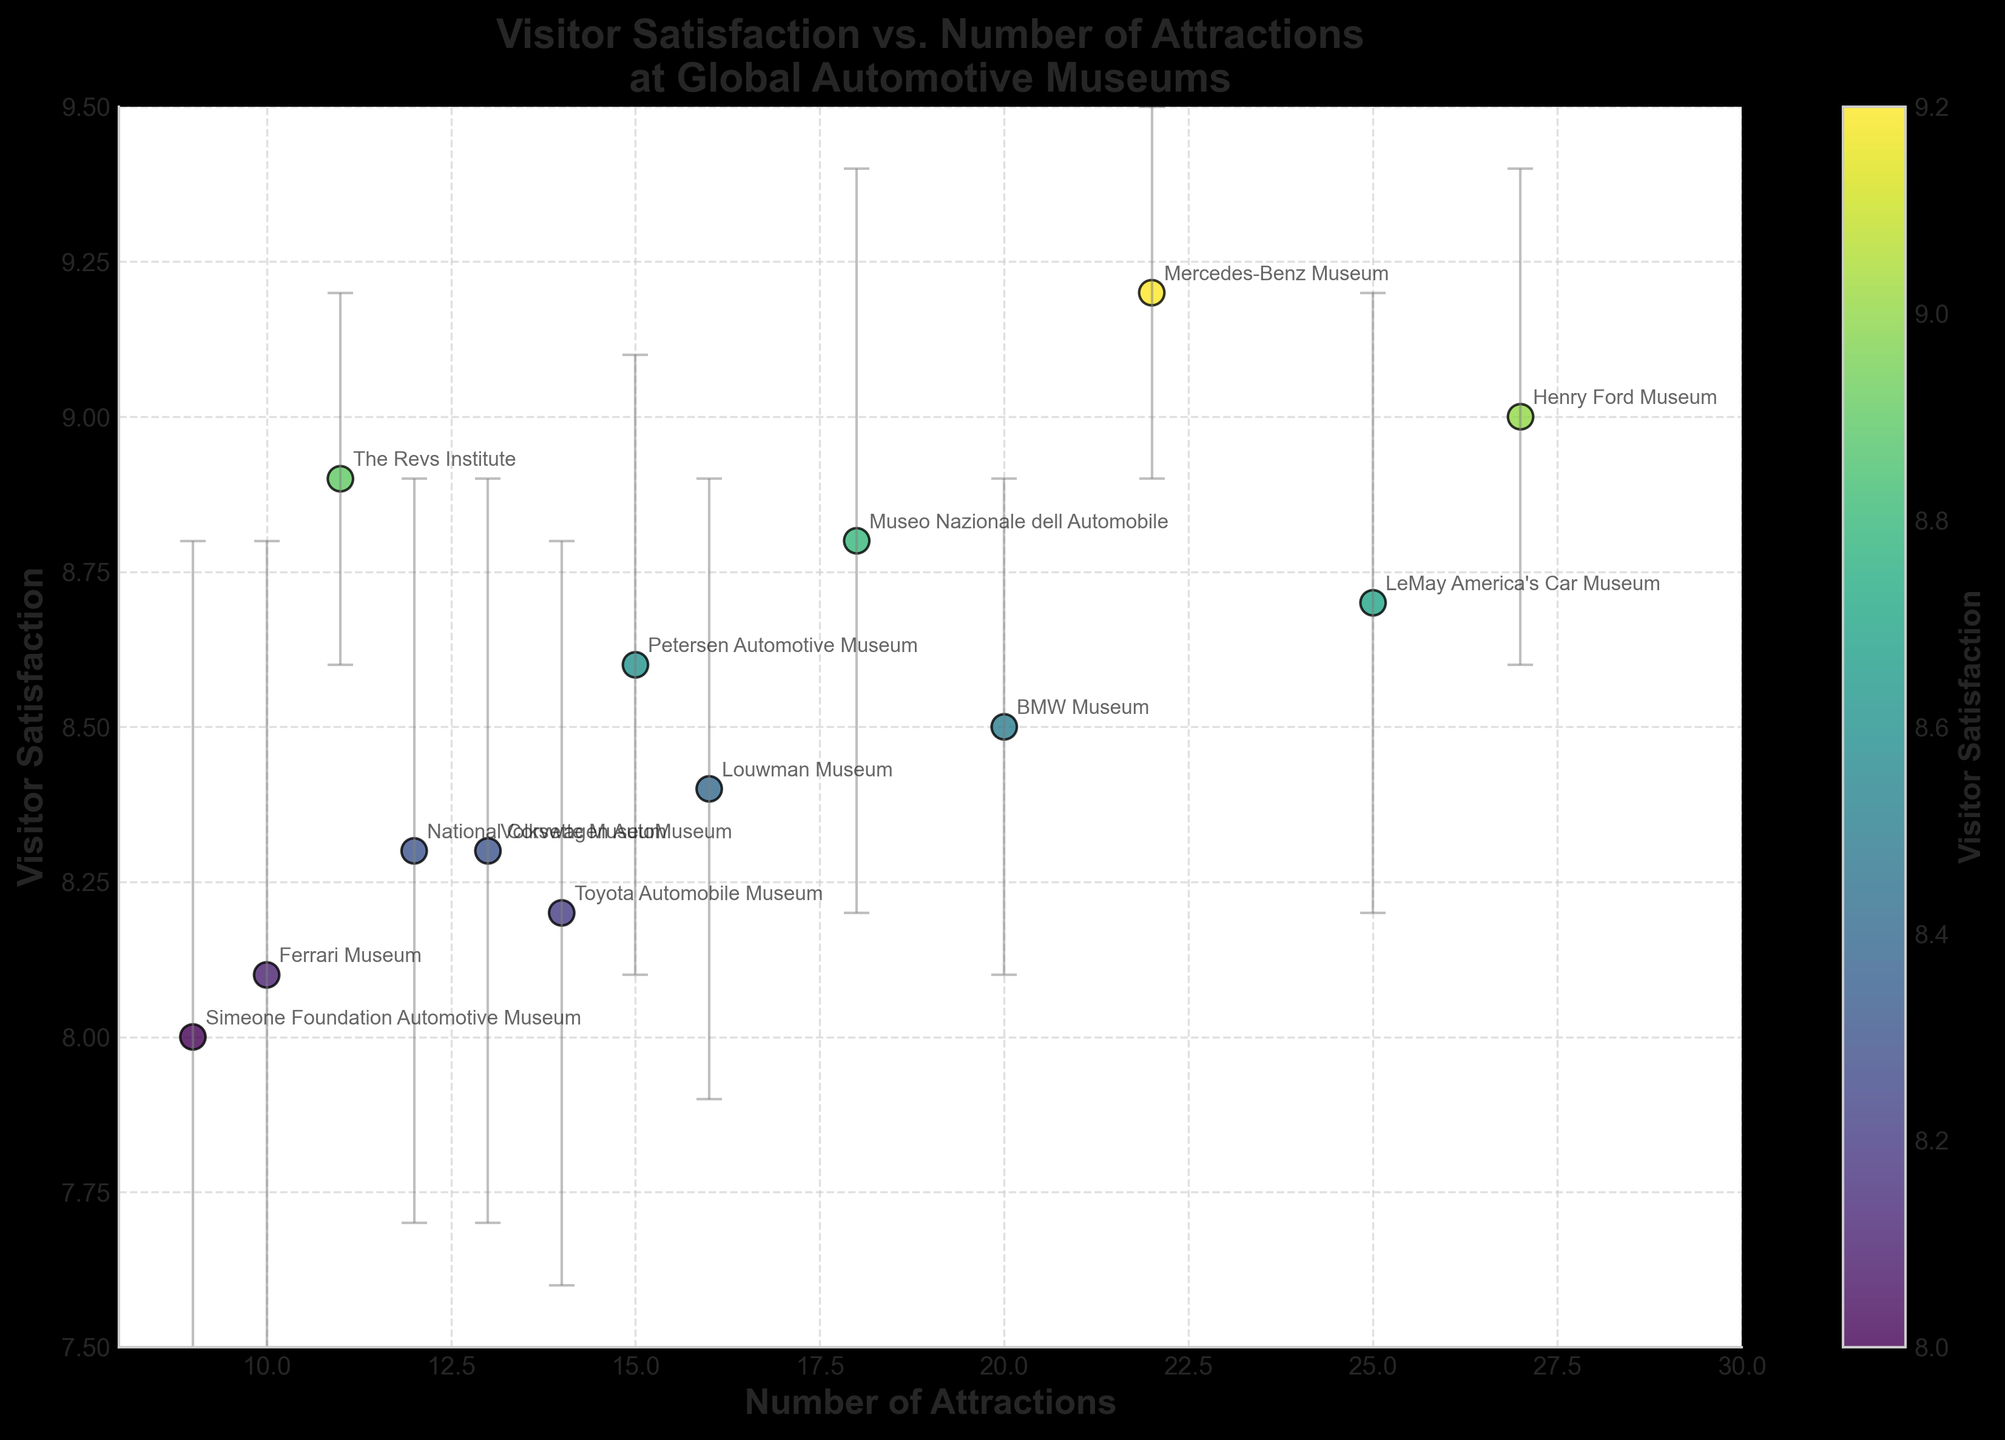How many museums are represented in the scatter plot? Count the total number of unique data points in the plot. Here, each data point represents a museum.
Answer: 13 What is the range of visitor satisfaction scores in the dataset? Identify the lowest and highest points on the y-axis representing Visitor Satisfaction values. The lowest is 8.0 (Simeone Foundation Automotive Museum), and the highest is 9.2 (Mercedes-Benz Museum). The range is 9.2 - 8.0.
Answer: 1.2 Which museum has the highest number of attractions? Check the x-axis for the data point that is farthest to the right. The museum with 27 attractions is the Henry Ford Museum.
Answer: Henry Ford Museum How does the visitor satisfaction of the Mercedes-Benz Museum compare to the Petersen Automotive Museum? Locate the points for both museums. Mercedes-Benz Museum has a higher satisfaction score (9.2) than the Petersen Automotive Museum (8.6).
Answer: Mercedes-Benz Museum has higher visitor satisfaction Which museum has the largest error range in visitor satisfaction? Look at the error bars and identify which one is the longest. Simeone Foundation Automotive Museum has the largest error range of 0.8.
Answer: Simeone Foundation Automotive Museum What is the visitor satisfaction score for the museum with 20 attractions? Find the point on the x-axis where Number of Attractions is 20. The visitor satisfaction score for the BMW Museum, which has 20 attractions, is 8.5.
Answer: 8.5 Which two museums have the closest visitor satisfaction scores and what are they? Identify the two points that are closest vertically on the y-axis. The BMW Museum (8.5) and Louwman Museum (8.4) have close visitor satisfaction scores.
Answer: BMW Museum and Louwman Museum; scores are 8.5 and 8.4 What is the average visitor satisfaction score of all museums? Sum all visitor satisfaction scores and divide by the number of museums. (8.6 + 9.2 + 8.1 + 9.0 + 8.8 + 8.5 + 8.3 + 8.7 + 8.2 + 8.9 + 8.0 + 8.4 + 8.3) /13 = 109.0 / 13 ≈ 8.38
Answer: 8.38 